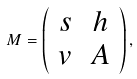<formula> <loc_0><loc_0><loc_500><loc_500>M = \left ( \begin{array} { c c } s & h \\ v & A \end{array} \right ) ,</formula> 